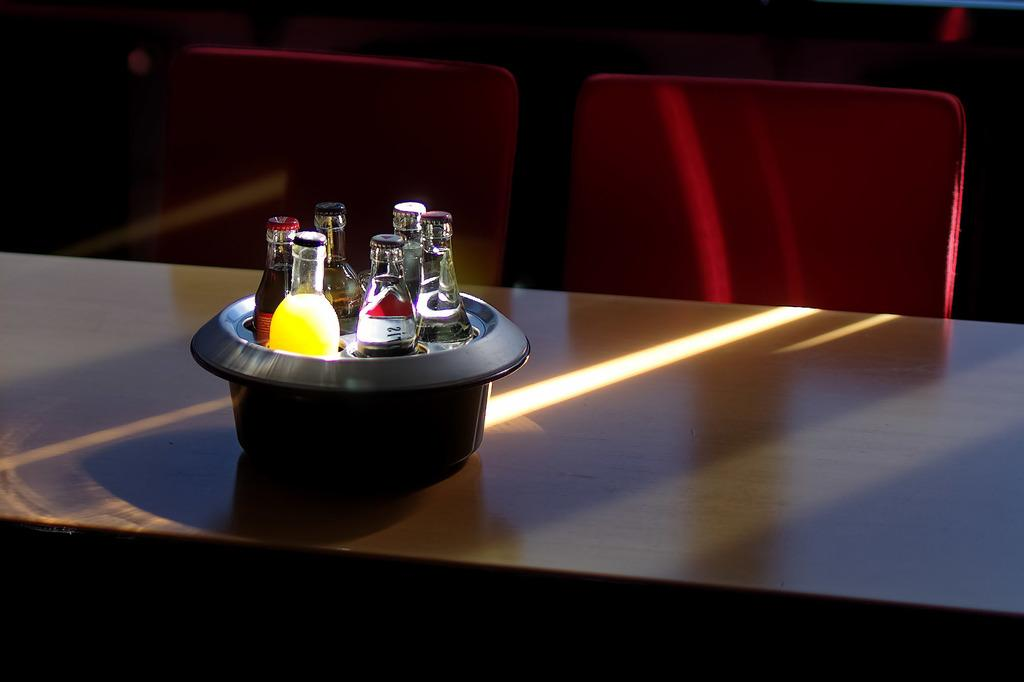What objects are visible in the image? There are bottles in the image. How are the bottles arranged? The bottles are packed in a bowl. Where is the bowl located? The bowl is on a table. What furniture is present near the table? There are two chairs in front of the table. What color is the ball that is floating above the table in the image? There is no ball present in the image; it only features bottles, a bowl, a table, and chairs. 